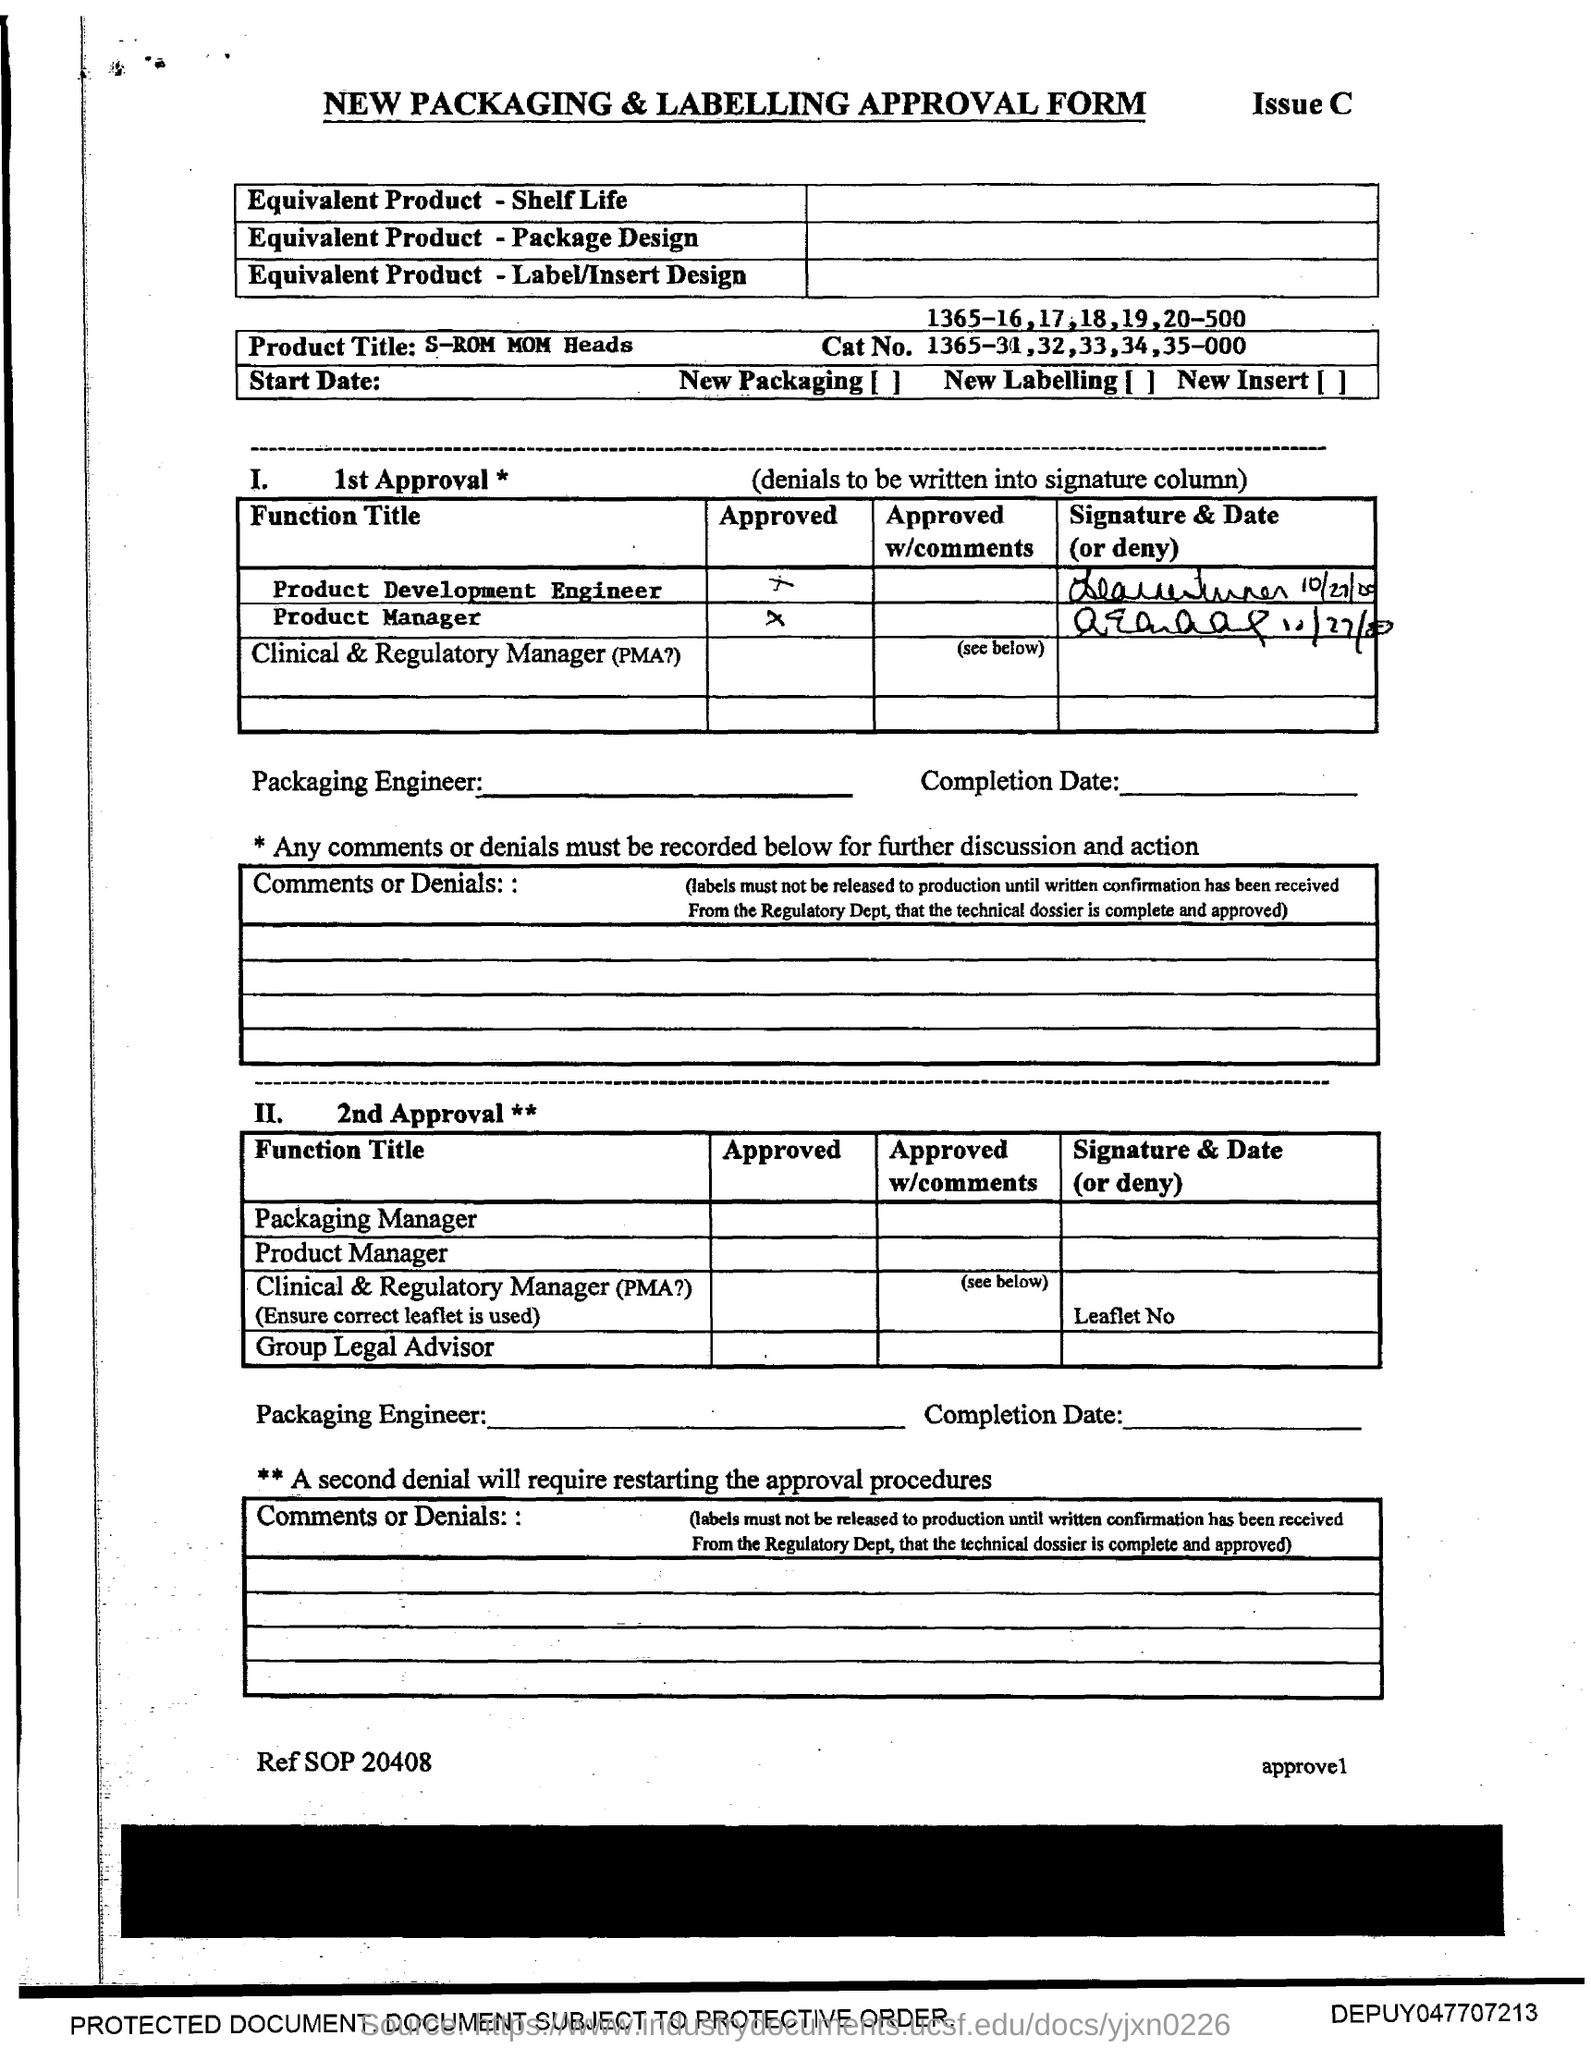What is the Product Title?
Provide a short and direct response. S-ROM MOM Heads. What is the Cat No.?
Ensure brevity in your answer.  1365-31,32,33,34,35-000. 